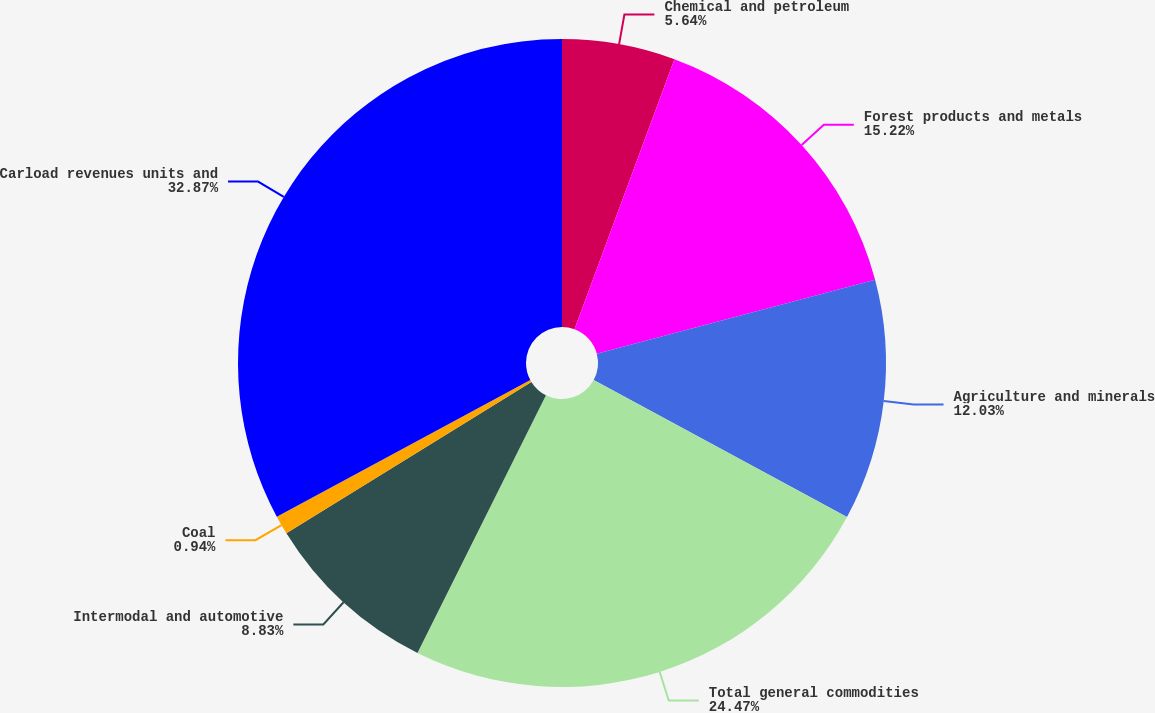Convert chart to OTSL. <chart><loc_0><loc_0><loc_500><loc_500><pie_chart><fcel>Chemical and petroleum<fcel>Forest products and metals<fcel>Agriculture and minerals<fcel>Total general commodities<fcel>Intermodal and automotive<fcel>Coal<fcel>Carload revenues units and<nl><fcel>5.64%<fcel>15.22%<fcel>12.03%<fcel>24.47%<fcel>8.83%<fcel>0.94%<fcel>32.87%<nl></chart> 